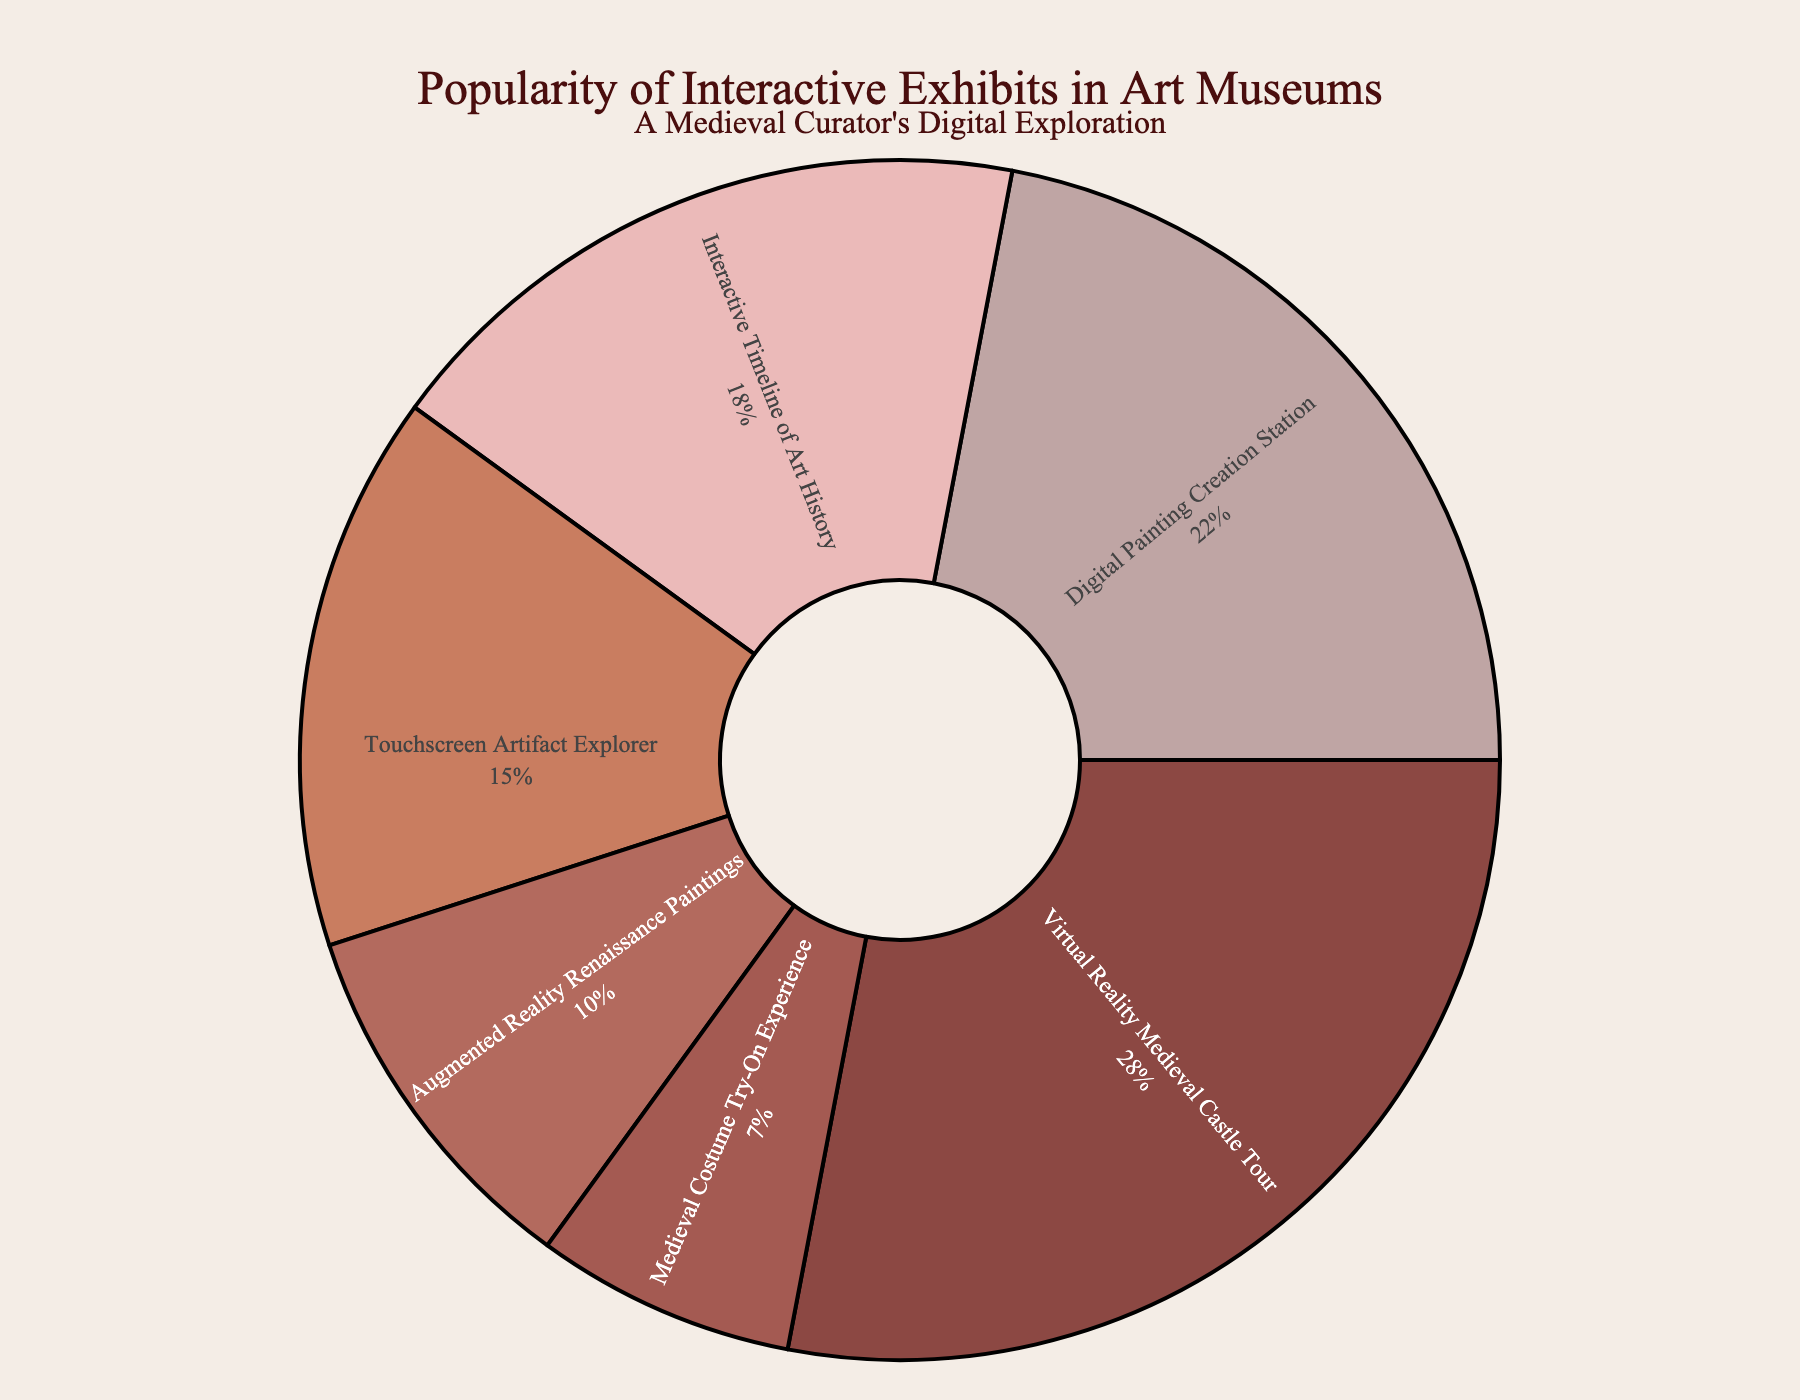Which interactive exhibit is the most popular? The exhibit with the highest percentage on the pie chart is the Virtual Reality Medieval Castle Tour.
Answer: Virtual Reality Medieval Castle Tour What is the combined popularity percentage of all interactive exhibits related to the Medieval period? Sum the percentages of the Virtual Reality Medieval Castle Tour (28%) and the Medieval Costume Try-On Experience (7%). 28 + 7 = 35
Answer: 35% Which exhibit has a higher popularity percentage: the Interactive Timeline of Art History or the Touchscreen Artifact Explorer? Compare the percentages of the Interactive Timeline of Art History (18%) and the Touchscreen Artifact Explorer (15%).
Answer: Interactive Timeline of Art History What is the least popular interactive exhibit? The exhibit with the smallest percentage on the pie chart is the Medieval Costume Try-On Experience.
Answer: Medieval Costume Try-On Experience How much more popular is the most popular exhibit compared to the least popular exhibit? Subtract the popularity percentage of the least popular exhibit (Medieval Costume Try-On Experience, 7%) from the most popular exhibit (Virtual Reality Medieval Castle Tour, 28%). 28 - 7 = 21
Answer: 21% If we combined the popularity percentages of the Digital Painting Creation Station and Augmented Reality Renaissance Paintings, what would be their total? Add the percentages of the Digital Painting Creation Station (22%) and the Augmented Reality Renaissance Paintings (10%). 22 + 10 = 32
Answer: 32% Which exhibit is represented by a light pinkish color in the pie chart? Examine the colors and find that the Interactive Timeline of Art History is represented by a light pinkish color.
Answer: Interactive Timeline of Art History Is the cumulative popularity of the Interactive Timeline of Art History and Touchscreen Artifact Explorer greater or less than the popularity of the Digital Painting Creation Station? Sum the percentages of the Interactive Timeline of Art History (18%) and the Touchscreen Artifact Explorer (15%) and compare with the Digital Painting Creation Station (22%). 18 + 15 = 33 > 22
Answer: Greater What is the difference in popularity percentages between the least popular and second least popular exhibits? Subtract the percentage of the Medieval Costume Try-On Experience (7%) from the Augmented Reality Renaissance Paintings (10%). 10 - 7 = 3
Answer: 3% If you combine the popularity percentages of the top two exhibits, what is the resulting percentage? Add the percentages of the Virtual Reality Medieval Castle Tour (28%) and the Digital Painting Creation Station (22%). 28 + 22 = 50
Answer: 50% 